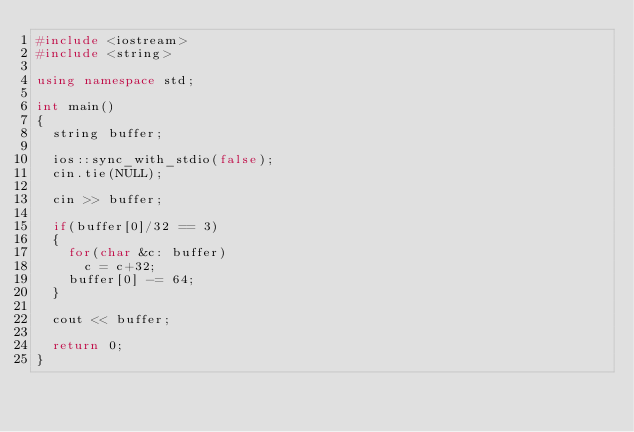<code> <loc_0><loc_0><loc_500><loc_500><_C++_>#include <iostream>
#include <string>

using namespace std;

int main()
{
	string buffer;

	ios::sync_with_stdio(false);
	cin.tie(NULL);

	cin >> buffer;

	if(buffer[0]/32 == 3)
	{
		for(char &c: buffer)
			c = c+32;
		buffer[0] -= 64;
	}

	cout << buffer;

	return 0;
}</code> 